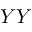Convert formula to latex. <formula><loc_0><loc_0><loc_500><loc_500>Y Y</formula> 